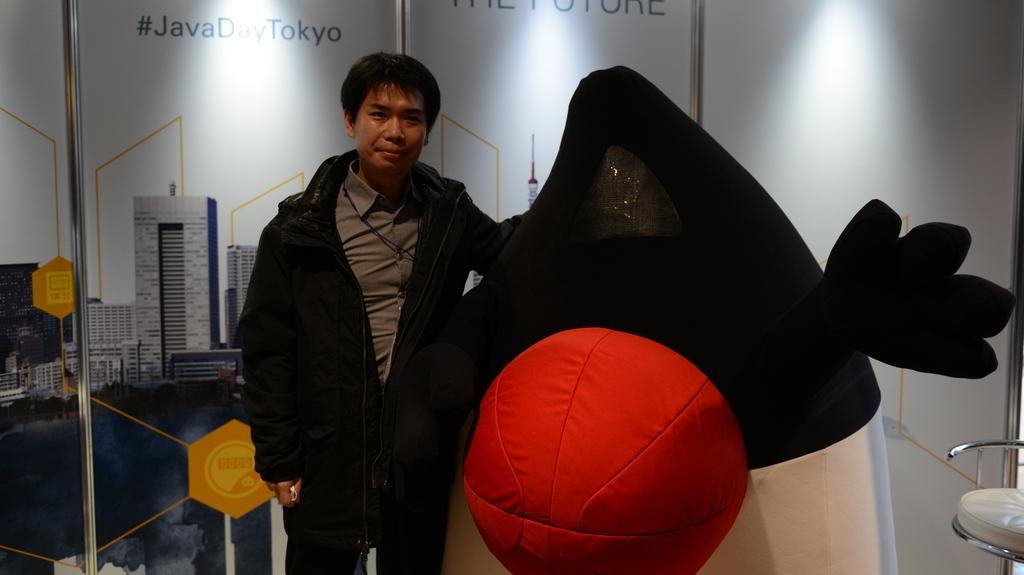Who is present in the image? There is a man in the image. What is the man doing in the image? The man is standing in the image. What can be seen beside the man? There are hoardings beside the man. Is there any furniture visible in the image? Yes, there is a chair in the image. What type of beef is being used as bait in the image? There is no beef or bait present in the image; it features a man standing beside hoardings with a chair nearby. 